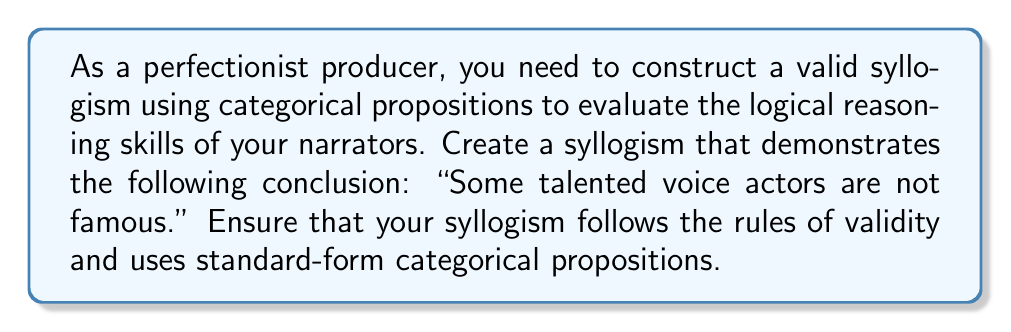Show me your answer to this math problem. To construct a valid syllogism, we need to follow these steps:

1. Identify the conclusion: "Some talented voice actors are not famous."

2. Determine the structure of the syllogism:
   - We need three terms: talented voice actors, famous people, and a middle term.
   - The conclusion is particular negative (SoP).

3. Choose a valid syllogism form that yields a particular negative conclusion. One such form is OAO-3:

   $\text{Minor Premise (O): Some M are not P}$
   $\text{Major Premise (A): All M are S}$
   $\text{Conclusion (O): Some S are not P}$

   Where:
   S = talented voice actors
   P = famous people
   M = middle term (e.g., award-winning performers)

4. Construct the syllogism:

   Minor Premise: Some award-winning performers are not famous.
   Major Premise: All award-winning performers are talented voice actors.
   Conclusion: Some talented voice actors are not famous.

5. Verify the validity:
   - The middle term (award-winning performers) is distributed in the major premise.
   - The conclusion is particular, following from the particular minor premise.
   - The syllogism follows the OAO-3 form, which is valid.

This syllogism is valid and uses standard-form categorical propositions:

$\text{Some M are not P}$: Particular Negative (O)
$\text{All M are S}$: Universal Affirmative (A)
$\text{Some S are not P}$: Particular Negative (O)
Answer: A valid syllogism using categorical propositions:

Minor Premise: Some award-winning performers are not famous.
Major Premise: All award-winning performers are talented voice actors.
Conclusion: Some talented voice actors are not famous. 